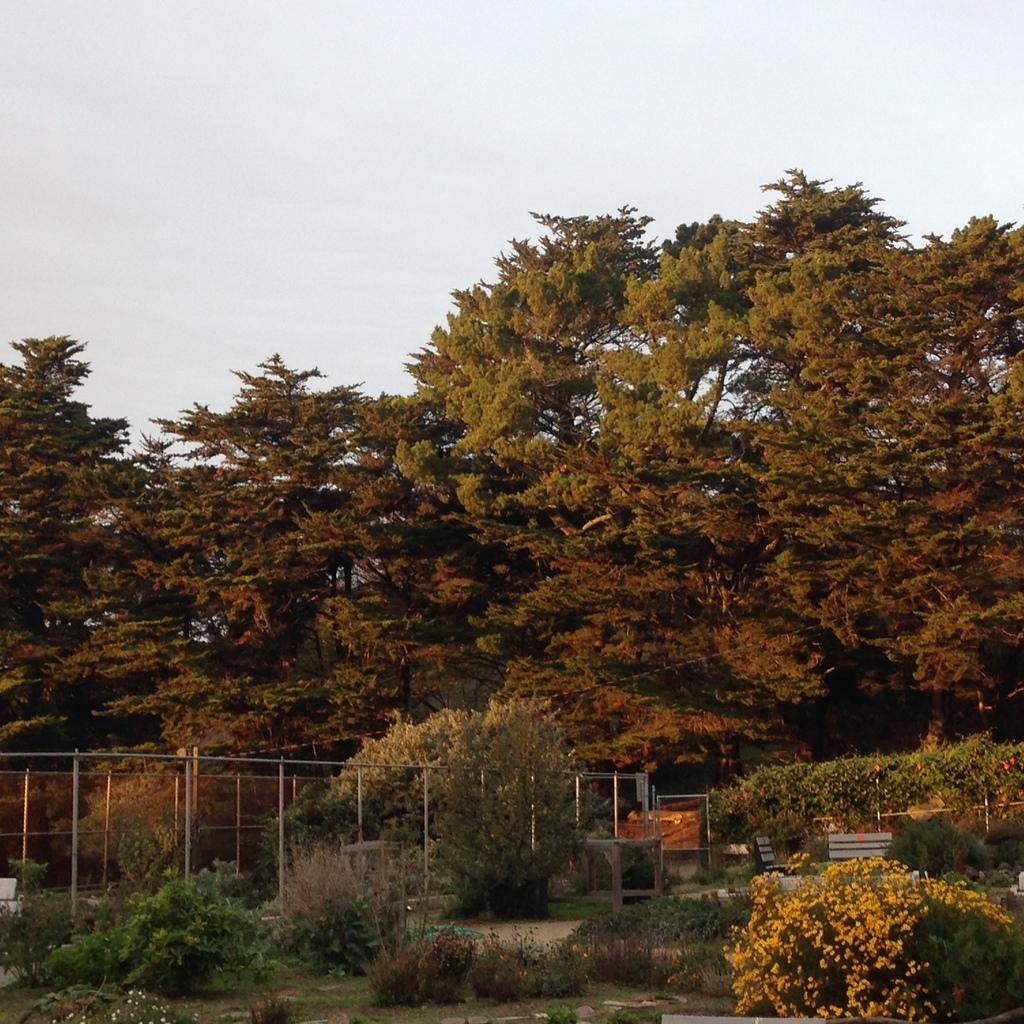What is the main subject of the image? The main subject of the image is a group of plants on a surface. What else can be seen in the image besides the plants? There is a fencing in the image. What is visible in the background of the image? There are groups of trees and a clear sky visible in the background of the image. What type of organization is responsible for the toys in the image? There are no toys present in the image, so it is not possible to determine which organization might be responsible for them. 